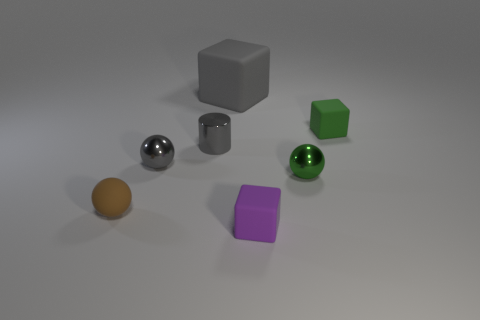Add 2 green cubes. How many objects exist? 9 Subtract all cylinders. How many objects are left? 6 Subtract all small cubes. Subtract all small shiny cylinders. How many objects are left? 4 Add 2 small shiny cylinders. How many small shiny cylinders are left? 3 Add 6 small purple rubber blocks. How many small purple rubber blocks exist? 7 Subtract 1 green blocks. How many objects are left? 6 